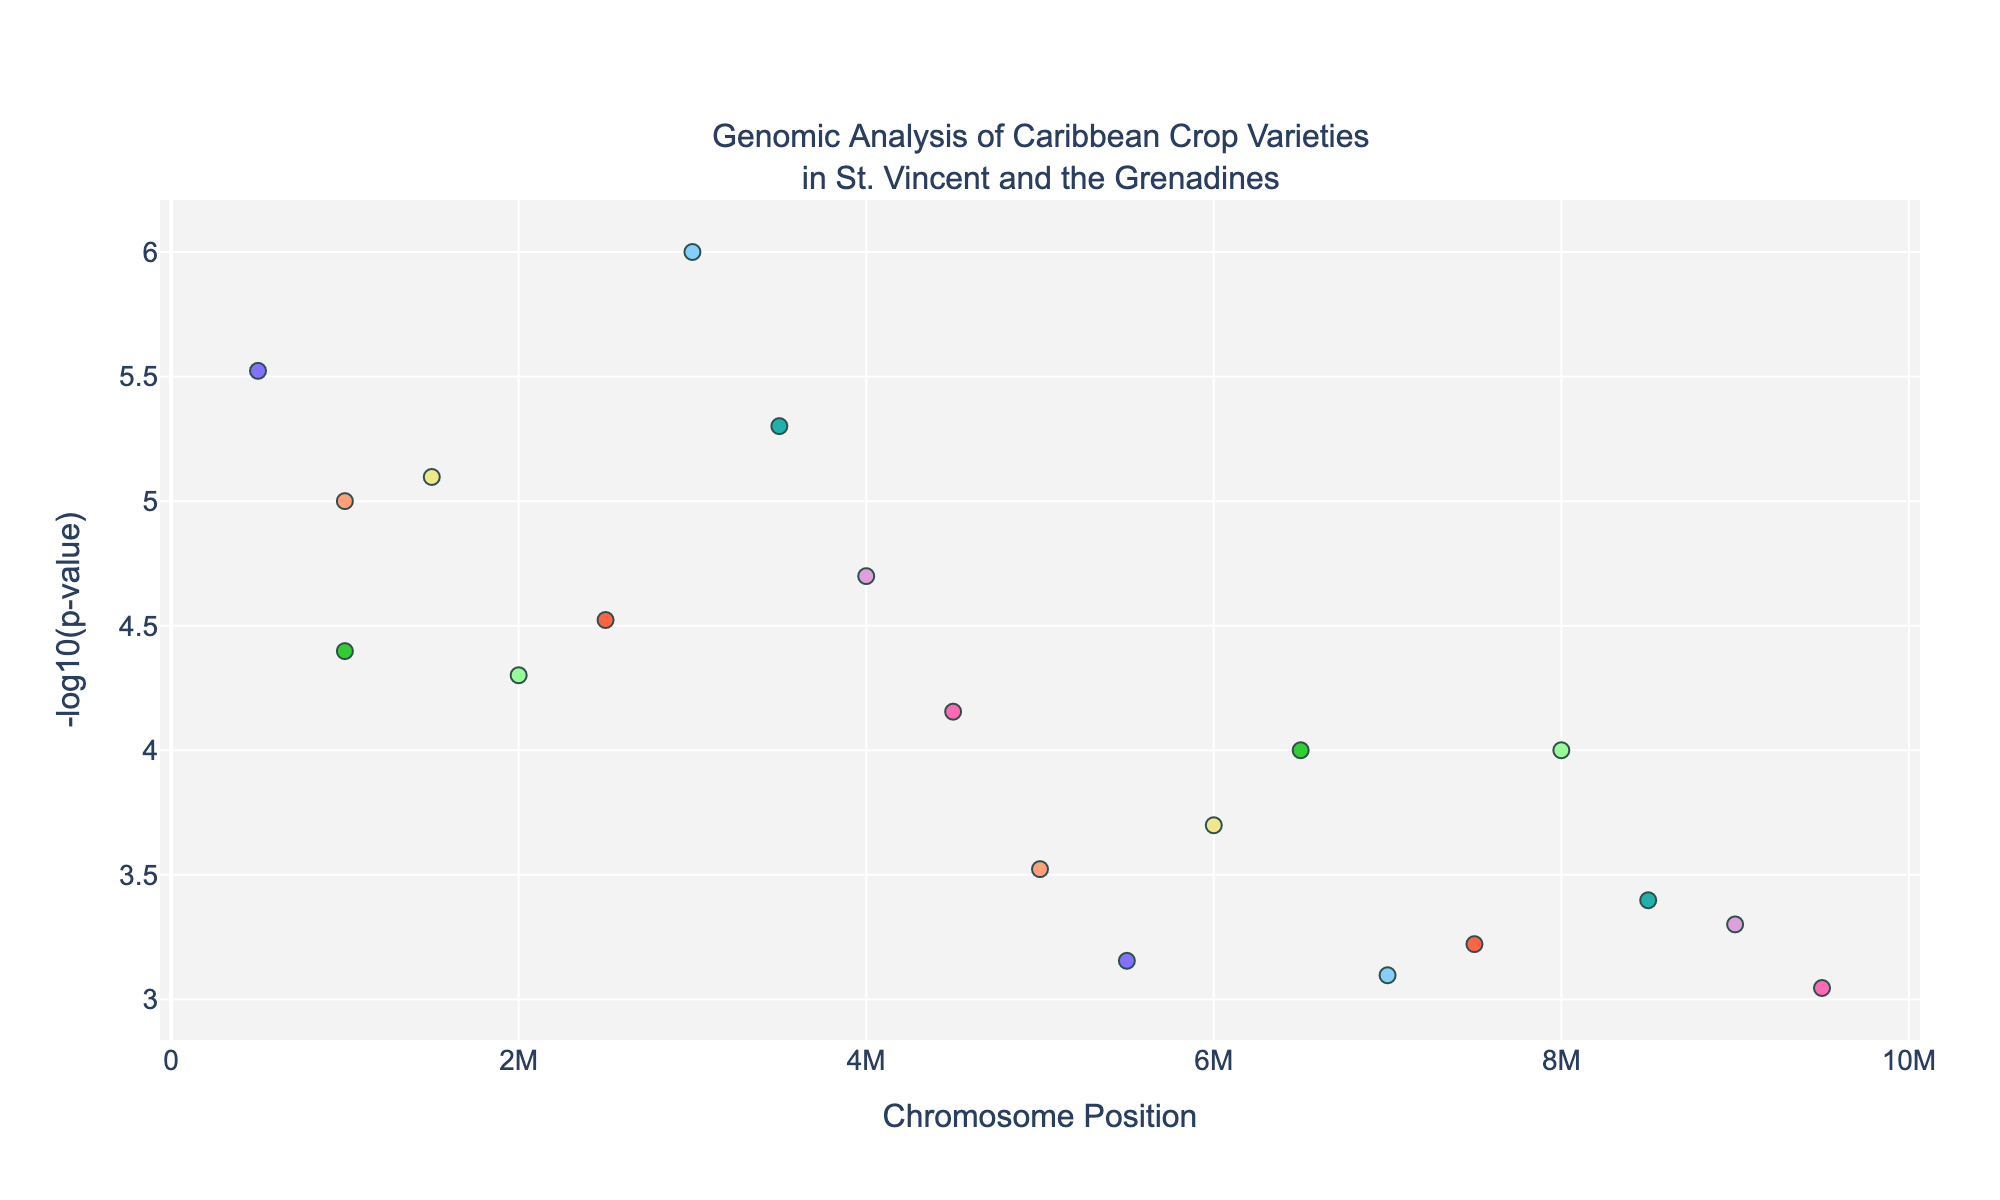Which chromosome has the data point with the highest -log10(p-value)? To find the chromosome with the highest -log10(p-value), look for the tallest point on the y-axis. Identify the associated chromosome from the x-axis and/or hover information.
Answer: Chromosome 3 What is the title of the plot? The title is usually found at the top of the plot.
Answer: Genomic Analysis of Caribbean Crop Varieties in St. Vincent and the Grenadines How many chromosomes are represented in the plot? Count the number of unique chromosome labels along the x-axis or from the legend.
Answer: 10 Which chromosome has the lowest -log10(p-value) point among all the data? Identify the shortest point(s) on the y-axis and determine the corresponding chromosome from the x-axis.
Answer: Chromosome 8 What is the -log10(p-value) for the marker associated with Soursop, Pulp Texture? Find the marker involving Soursop and Pulp Texture by hovering or locating it on the x-axis, then read the y-axis value for that point.
Answer: 5.52288 Which crop associated with Chromosome 5 has the highest -log10(p-value)? Focus on data points in Chromosome 5 and compare their y-axis values; identify the corresponding crop.
Answer: Dasheen How does the number of data points for Mango compare to Pineapple? Count the markers for Mango and Pineapple and compare their numbers.
Answer: Equal Which chromosome position has the widest range in -log10(p-value) among all crops? Examine the spread of -log10(p-value) values within each chromosome and identify the one with the largest range (difference between max and min).
Answer: Chromosome 9 What is the color of the markers representing Chromosome 2? Look for the color of the markers specifically associated with Chromosome 2 on the plot.
Answer: Green (#98FB98) Which crop has a marker at the highest position on Chromosome 1? Identify the highest marker on the y-axis for Chromosome 1 and determine the corresponding crop from the hover information.
Answer: Banana 